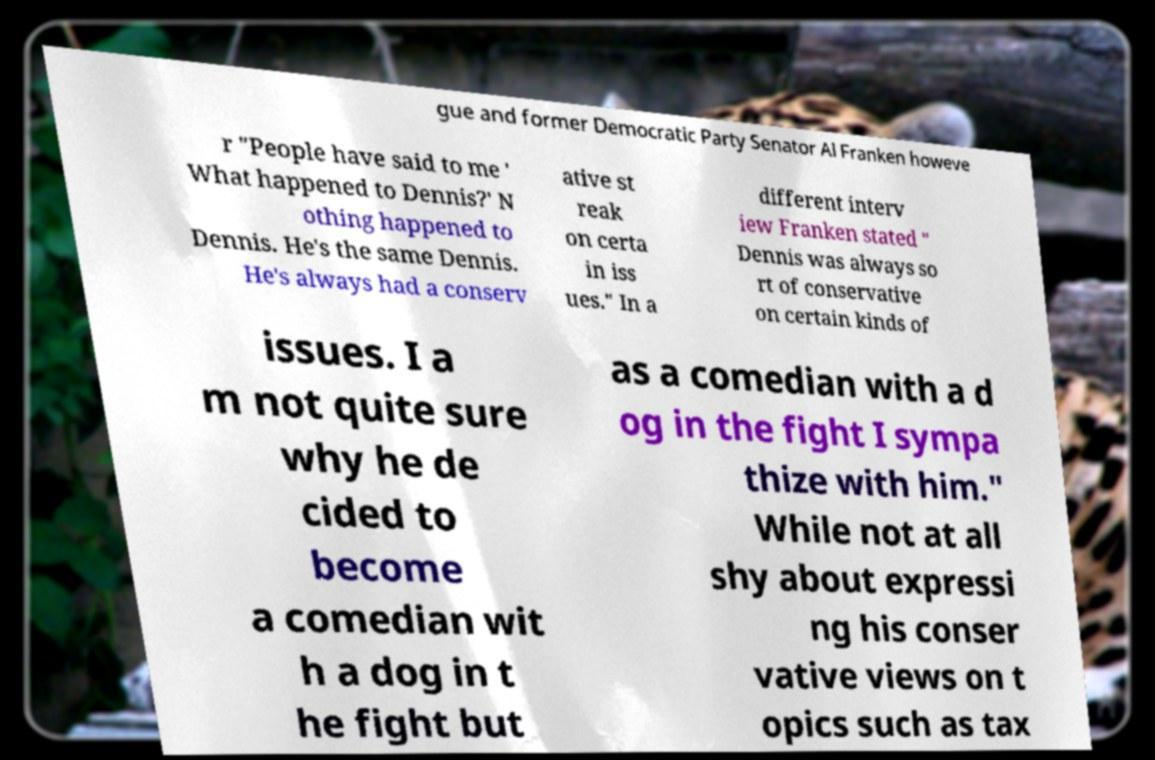Please identify and transcribe the text found in this image. gue and former Democratic Party Senator Al Franken howeve r "People have said to me ' What happened to Dennis?' N othing happened to Dennis. He's the same Dennis. He's always had a conserv ative st reak on certa in iss ues." In a different interv iew Franken stated " Dennis was always so rt of conservative on certain kinds of issues. I a m not quite sure why he de cided to become a comedian wit h a dog in t he fight but as a comedian with a d og in the fight I sympa thize with him." While not at all shy about expressi ng his conser vative views on t opics such as tax 